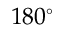Convert formula to latex. <formula><loc_0><loc_0><loc_500><loc_500>1 8 0 ^ { \circ }</formula> 